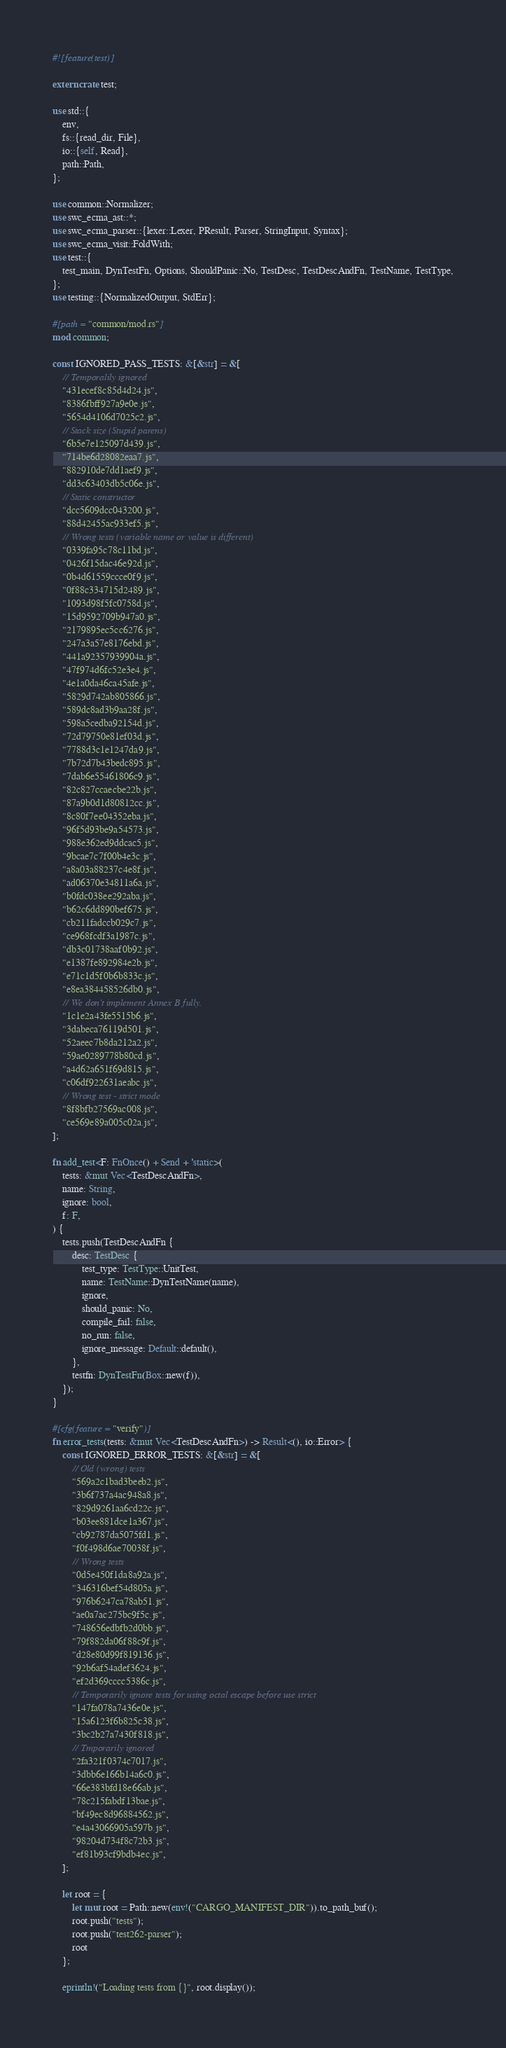Convert code to text. <code><loc_0><loc_0><loc_500><loc_500><_Rust_>#![feature(test)]

extern crate test;

use std::{
    env,
    fs::{read_dir, File},
    io::{self, Read},
    path::Path,
};

use common::Normalizer;
use swc_ecma_ast::*;
use swc_ecma_parser::{lexer::Lexer, PResult, Parser, StringInput, Syntax};
use swc_ecma_visit::FoldWith;
use test::{
    test_main, DynTestFn, Options, ShouldPanic::No, TestDesc, TestDescAndFn, TestName, TestType,
};
use testing::{NormalizedOutput, StdErr};

#[path = "common/mod.rs"]
mod common;

const IGNORED_PASS_TESTS: &[&str] = &[
    // Temporalily ignored
    "431ecef8c85d4d24.js",
    "8386fbff927a9e0e.js",
    "5654d4106d7025c2.js",
    // Stack size (Stupid parens)
    "6b5e7e125097d439.js",
    "714be6d28082eaa7.js",
    "882910de7dd1aef9.js",
    "dd3c63403db5c06e.js",
    // Static constructor
    "dcc5609dcc043200.js",
    "88d42455ac933ef5.js",
    // Wrong tests (variable name or value is different)
    "0339fa95c78c11bd.js",
    "0426f15dac46e92d.js",
    "0b4d61559ccce0f9.js",
    "0f88c334715d2489.js",
    "1093d98f5fc0758d.js",
    "15d9592709b947a0.js",
    "2179895ec5cc6276.js",
    "247a3a57e8176ebd.js",
    "441a92357939904a.js",
    "47f974d6fc52e3e4.js",
    "4e1a0da46ca45afe.js",
    "5829d742ab805866.js",
    "589dc8ad3b9aa28f.js",
    "598a5cedba92154d.js",
    "72d79750e81ef03d.js",
    "7788d3c1e1247da9.js",
    "7b72d7b43bedc895.js",
    "7dab6e55461806c9.js",
    "82c827ccaecbe22b.js",
    "87a9b0d1d80812cc.js",
    "8c80f7ee04352eba.js",
    "96f5d93be9a54573.js",
    "988e362ed9ddcac5.js",
    "9bcae7c7f00b4e3c.js",
    "a8a03a88237c4e8f.js",
    "ad06370e34811a6a.js",
    "b0fdc038ee292aba.js",
    "b62c6dd890bef675.js",
    "cb211fadccb029c7.js",
    "ce968fcdf3a1987c.js",
    "db3c01738aaf0b92.js",
    "e1387fe892984e2b.js",
    "e71c1d5f0b6b833c.js",
    "e8ea384458526db0.js",
    // We don't implement Annex B fully.
    "1c1e2a43fe5515b6.js",
    "3dabeca76119d501.js",
    "52aeec7b8da212a2.js",
    "59ae0289778b80cd.js",
    "a4d62a651f69d815.js",
    "c06df922631aeabc.js",
    // Wrong test - strict mode
    "8f8bfb27569ac008.js",
    "ce569e89a005c02a.js",
];

fn add_test<F: FnOnce() + Send + 'static>(
    tests: &mut Vec<TestDescAndFn>,
    name: String,
    ignore: bool,
    f: F,
) {
    tests.push(TestDescAndFn {
        desc: TestDesc {
            test_type: TestType::UnitTest,
            name: TestName::DynTestName(name),
            ignore,
            should_panic: No,
            compile_fail: false,
            no_run: false,
            ignore_message: Default::default(),
        },
        testfn: DynTestFn(Box::new(f)),
    });
}

#[cfg(feature = "verify")]
fn error_tests(tests: &mut Vec<TestDescAndFn>) -> Result<(), io::Error> {
    const IGNORED_ERROR_TESTS: &[&str] = &[
        // Old (wrong) tests
        "569a2c1bad3beeb2.js",
        "3b6f737a4ac948a8.js",
        "829d9261aa6cd22c.js",
        "b03ee881dce1a367.js",
        "cb92787da5075fd1.js",
        "f0f498d6ae70038f.js",
        // Wrong tests
        "0d5e450f1da8a92a.js",
        "346316bef54d805a.js",
        "976b6247ca78ab51.js",
        "ae0a7ac275bc9f5c.js",
        "748656edbfb2d0bb.js",
        "79f882da06f88c9f.js",
        "d28e80d99f819136.js",
        "92b6af54adef3624.js",
        "ef2d369cccc5386c.js",
        // Temporarily ignore tests for using octal escape before use strict
        "147fa078a7436e0e.js",
        "15a6123f6b825c38.js",
        "3bc2b27a7430f818.js",
        // Tmporarily ignored
        "2fa321f0374c7017.js",
        "3dbb6e166b14a6c0.js",
        "66e383bfd18e66ab.js",
        "78c215fabdf13bae.js",
        "bf49ec8d96884562.js",
        "e4a43066905a597b.js",
        "98204d734f8c72b3.js",
        "ef81b93cf9bdb4ec.js",
    ];

    let root = {
        let mut root = Path::new(env!("CARGO_MANIFEST_DIR")).to_path_buf();
        root.push("tests");
        root.push("test262-parser");
        root
    };

    eprintln!("Loading tests from {}", root.display());
</code> 